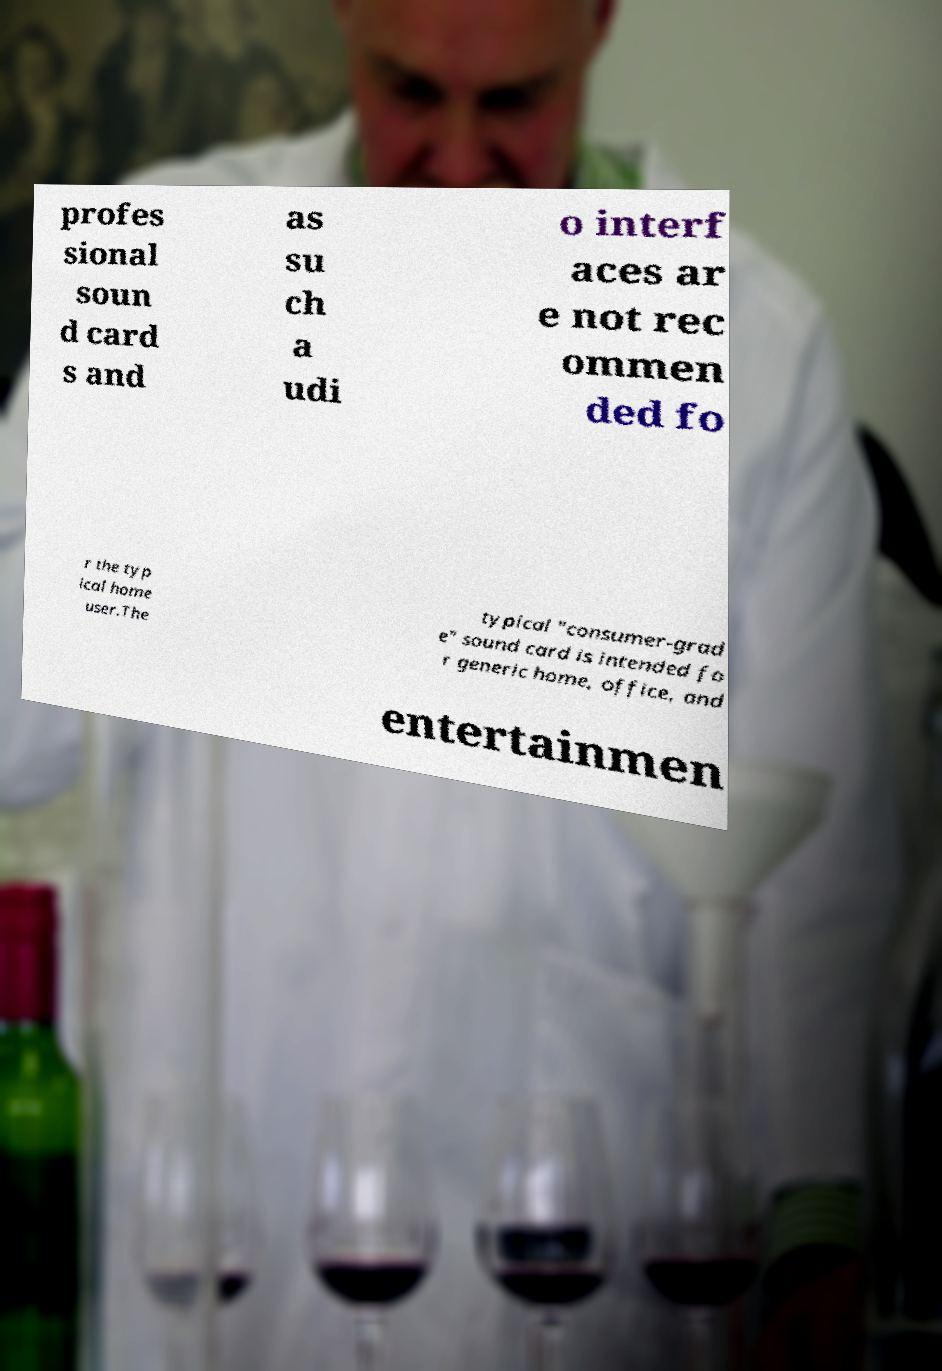Can you read and provide the text displayed in the image?This photo seems to have some interesting text. Can you extract and type it out for me? profes sional soun d card s and as su ch a udi o interf aces ar e not rec ommen ded fo r the typ ical home user.The typical "consumer-grad e" sound card is intended fo r generic home, office, and entertainmen 